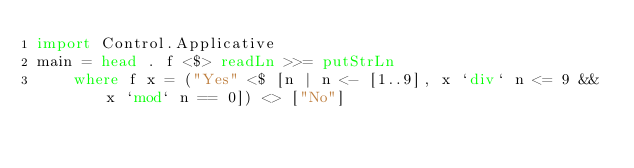<code> <loc_0><loc_0><loc_500><loc_500><_Haskell_>import Control.Applicative
main = head . f <$> readLn >>= putStrLn
    where f x = ("Yes" <$ [n | n <- [1..9], x `div` n <= 9 && x `mod` n == 0]) <> ["No"]</code> 